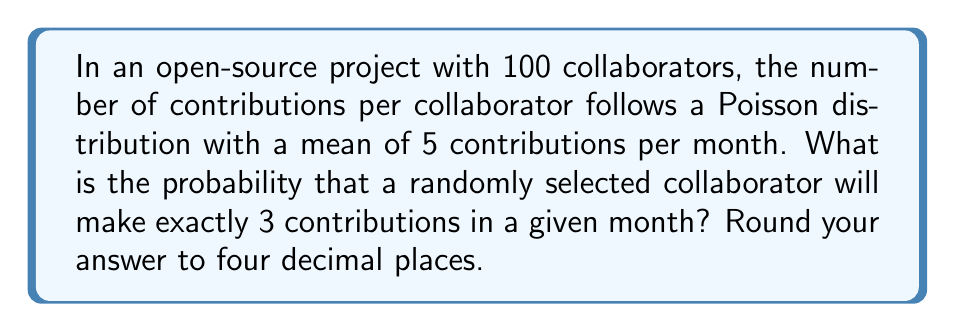Can you solve this math problem? Let's approach this step-by-step:

1) The Poisson distribution is given by the formula:

   $$P(X = k) = \frac{e^{-\lambda} \lambda^k}{k!}$$

   where:
   - $\lambda$ is the average number of events in the interval
   - $k$ is the number of events we're interested in
   - $e$ is Euler's number (approximately 2.71828)

2) In this case:
   - $\lambda = 5$ (mean number of contributions per month)
   - $k = 3$ (we're interested in exactly 3 contributions)

3) Let's substitute these values into the formula:

   $$P(X = 3) = \frac{e^{-5} 5^3}{3!}$$

4) Now, let's calculate step by step:
   
   a) First, calculate $5^3 = 125$
   
   b) Calculate $3! = 3 \times 2 \times 1 = 6$
   
   c) Calculate $e^{-5} \approx 0.00673795$

5) Substituting these values:

   $$P(X = 3) = \frac{0.00673795 \times 125}{6}$$

6) Simplifying:

   $$P(X = 3) = 0.14037395$$

7) Rounding to four decimal places:

   $$P(X = 3) \approx 0.1404$$
Answer: 0.1404 